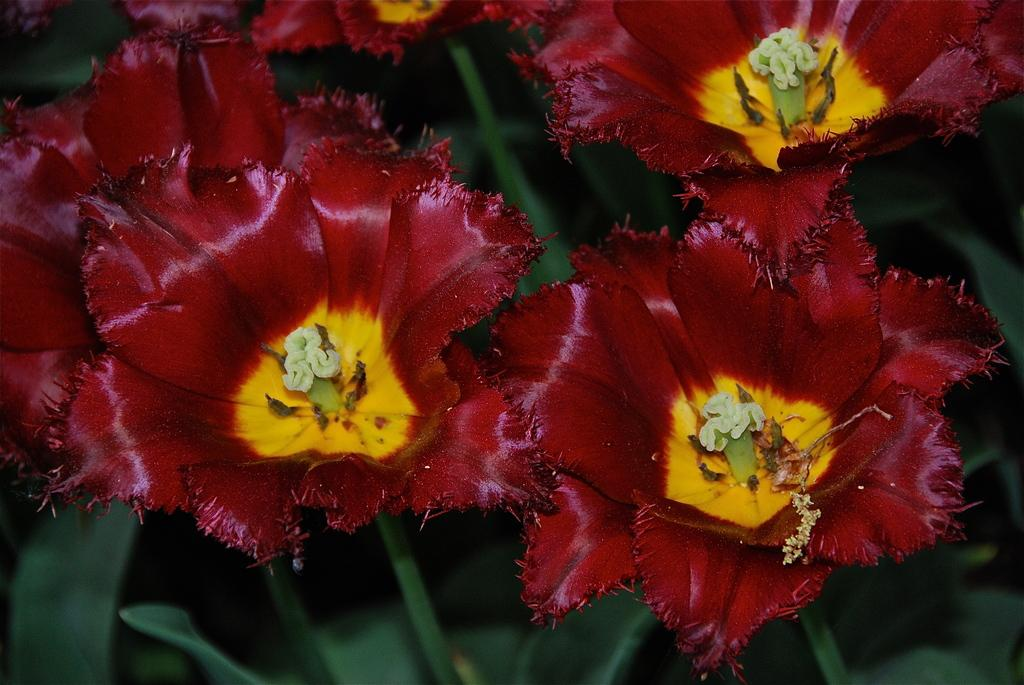What color are the flowers in the image? The flowers in the image are maroon color. What are the flowers attached to? The flowers are on plants. What disease is the plant suffering from in the image? There is no indication of any disease in the image; the flowers and plants appear healthy. 